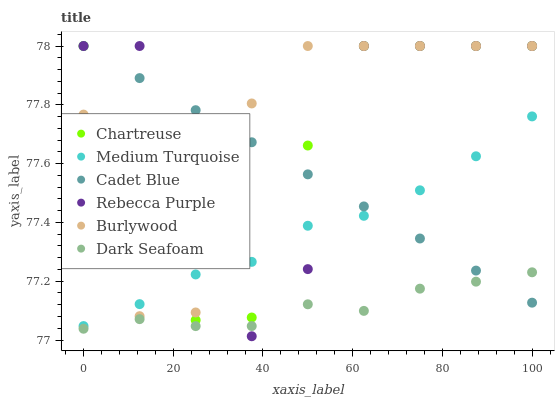Does Dark Seafoam have the minimum area under the curve?
Answer yes or no. Yes. Does Burlywood have the maximum area under the curve?
Answer yes or no. Yes. Does Chartreuse have the minimum area under the curve?
Answer yes or no. No. Does Chartreuse have the maximum area under the curve?
Answer yes or no. No. Is Cadet Blue the smoothest?
Answer yes or no. Yes. Is Rebecca Purple the roughest?
Answer yes or no. Yes. Is Burlywood the smoothest?
Answer yes or no. No. Is Burlywood the roughest?
Answer yes or no. No. Does Rebecca Purple have the lowest value?
Answer yes or no. Yes. Does Burlywood have the lowest value?
Answer yes or no. No. Does Rebecca Purple have the highest value?
Answer yes or no. Yes. Does Dark Seafoam have the highest value?
Answer yes or no. No. Is Dark Seafoam less than Chartreuse?
Answer yes or no. Yes. Is Medium Turquoise greater than Dark Seafoam?
Answer yes or no. Yes. Does Rebecca Purple intersect Dark Seafoam?
Answer yes or no. Yes. Is Rebecca Purple less than Dark Seafoam?
Answer yes or no. No. Is Rebecca Purple greater than Dark Seafoam?
Answer yes or no. No. Does Dark Seafoam intersect Chartreuse?
Answer yes or no. No. 